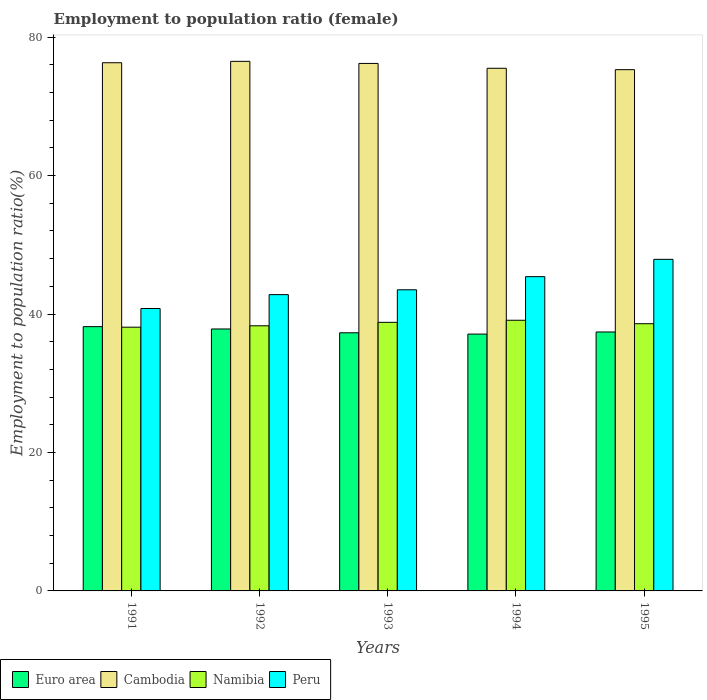Are the number of bars per tick equal to the number of legend labels?
Ensure brevity in your answer.  Yes. What is the label of the 3rd group of bars from the left?
Ensure brevity in your answer.  1993. What is the employment to population ratio in Euro area in 1995?
Keep it short and to the point. 37.41. Across all years, what is the maximum employment to population ratio in Namibia?
Your response must be concise. 39.1. Across all years, what is the minimum employment to population ratio in Cambodia?
Your response must be concise. 75.3. In which year was the employment to population ratio in Euro area maximum?
Your answer should be very brief. 1991. In which year was the employment to population ratio in Namibia minimum?
Ensure brevity in your answer.  1991. What is the total employment to population ratio in Euro area in the graph?
Provide a short and direct response. 187.81. What is the difference between the employment to population ratio in Namibia in 1991 and that in 1992?
Your response must be concise. -0.2. What is the difference between the employment to population ratio in Peru in 1993 and the employment to population ratio in Euro area in 1991?
Give a very brief answer. 5.32. What is the average employment to population ratio in Euro area per year?
Provide a succinct answer. 37.56. In the year 1994, what is the difference between the employment to population ratio in Cambodia and employment to population ratio in Namibia?
Keep it short and to the point. 36.4. What is the ratio of the employment to population ratio in Cambodia in 1992 to that in 1995?
Provide a short and direct response. 1.02. Is the employment to population ratio in Cambodia in 1993 less than that in 1995?
Make the answer very short. No. What is the difference between the highest and the second highest employment to population ratio in Peru?
Provide a short and direct response. 2.5. In how many years, is the employment to population ratio in Namibia greater than the average employment to population ratio in Namibia taken over all years?
Ensure brevity in your answer.  3. What does the 3rd bar from the left in 1994 represents?
Offer a very short reply. Namibia. How many bars are there?
Give a very brief answer. 20. How many years are there in the graph?
Offer a very short reply. 5. What is the difference between two consecutive major ticks on the Y-axis?
Give a very brief answer. 20. Does the graph contain any zero values?
Make the answer very short. No. Does the graph contain grids?
Provide a succinct answer. No. Where does the legend appear in the graph?
Ensure brevity in your answer.  Bottom left. How many legend labels are there?
Ensure brevity in your answer.  4. How are the legend labels stacked?
Ensure brevity in your answer.  Horizontal. What is the title of the graph?
Make the answer very short. Employment to population ratio (female). Does "Macao" appear as one of the legend labels in the graph?
Ensure brevity in your answer.  No. What is the label or title of the X-axis?
Your answer should be compact. Years. What is the Employment to population ratio(%) of Euro area in 1991?
Offer a terse response. 38.18. What is the Employment to population ratio(%) in Cambodia in 1991?
Make the answer very short. 76.3. What is the Employment to population ratio(%) in Namibia in 1991?
Give a very brief answer. 38.1. What is the Employment to population ratio(%) in Peru in 1991?
Your answer should be compact. 40.8. What is the Employment to population ratio(%) of Euro area in 1992?
Make the answer very short. 37.84. What is the Employment to population ratio(%) of Cambodia in 1992?
Keep it short and to the point. 76.5. What is the Employment to population ratio(%) of Namibia in 1992?
Your answer should be compact. 38.3. What is the Employment to population ratio(%) of Peru in 1992?
Offer a terse response. 42.8. What is the Employment to population ratio(%) of Euro area in 1993?
Ensure brevity in your answer.  37.29. What is the Employment to population ratio(%) in Cambodia in 1993?
Offer a very short reply. 76.2. What is the Employment to population ratio(%) in Namibia in 1993?
Offer a very short reply. 38.8. What is the Employment to population ratio(%) in Peru in 1993?
Make the answer very short. 43.5. What is the Employment to population ratio(%) of Euro area in 1994?
Provide a short and direct response. 37.1. What is the Employment to population ratio(%) in Cambodia in 1994?
Make the answer very short. 75.5. What is the Employment to population ratio(%) in Namibia in 1994?
Your answer should be very brief. 39.1. What is the Employment to population ratio(%) in Peru in 1994?
Your answer should be compact. 45.4. What is the Employment to population ratio(%) in Euro area in 1995?
Provide a succinct answer. 37.41. What is the Employment to population ratio(%) in Cambodia in 1995?
Provide a short and direct response. 75.3. What is the Employment to population ratio(%) of Namibia in 1995?
Offer a very short reply. 38.6. What is the Employment to population ratio(%) in Peru in 1995?
Offer a very short reply. 47.9. Across all years, what is the maximum Employment to population ratio(%) of Euro area?
Provide a succinct answer. 38.18. Across all years, what is the maximum Employment to population ratio(%) of Cambodia?
Your answer should be compact. 76.5. Across all years, what is the maximum Employment to population ratio(%) in Namibia?
Ensure brevity in your answer.  39.1. Across all years, what is the maximum Employment to population ratio(%) in Peru?
Offer a very short reply. 47.9. Across all years, what is the minimum Employment to population ratio(%) of Euro area?
Make the answer very short. 37.1. Across all years, what is the minimum Employment to population ratio(%) of Cambodia?
Offer a very short reply. 75.3. Across all years, what is the minimum Employment to population ratio(%) of Namibia?
Offer a very short reply. 38.1. Across all years, what is the minimum Employment to population ratio(%) of Peru?
Make the answer very short. 40.8. What is the total Employment to population ratio(%) in Euro area in the graph?
Your response must be concise. 187.81. What is the total Employment to population ratio(%) in Cambodia in the graph?
Offer a very short reply. 379.8. What is the total Employment to population ratio(%) of Namibia in the graph?
Keep it short and to the point. 192.9. What is the total Employment to population ratio(%) of Peru in the graph?
Make the answer very short. 220.4. What is the difference between the Employment to population ratio(%) of Euro area in 1991 and that in 1992?
Offer a very short reply. 0.34. What is the difference between the Employment to population ratio(%) of Cambodia in 1991 and that in 1992?
Provide a succinct answer. -0.2. What is the difference between the Employment to population ratio(%) of Euro area in 1991 and that in 1993?
Provide a succinct answer. 0.89. What is the difference between the Employment to population ratio(%) in Cambodia in 1991 and that in 1993?
Ensure brevity in your answer.  0.1. What is the difference between the Employment to population ratio(%) in Namibia in 1991 and that in 1993?
Give a very brief answer. -0.7. What is the difference between the Employment to population ratio(%) of Peru in 1991 and that in 1993?
Provide a short and direct response. -2.7. What is the difference between the Employment to population ratio(%) of Euro area in 1991 and that in 1994?
Offer a very short reply. 1.07. What is the difference between the Employment to population ratio(%) in Cambodia in 1991 and that in 1994?
Your answer should be very brief. 0.8. What is the difference between the Employment to population ratio(%) of Namibia in 1991 and that in 1994?
Give a very brief answer. -1. What is the difference between the Employment to population ratio(%) of Peru in 1991 and that in 1994?
Your answer should be very brief. -4.6. What is the difference between the Employment to population ratio(%) in Euro area in 1991 and that in 1995?
Provide a succinct answer. 0.77. What is the difference between the Employment to population ratio(%) of Euro area in 1992 and that in 1993?
Make the answer very short. 0.55. What is the difference between the Employment to population ratio(%) in Cambodia in 1992 and that in 1993?
Your answer should be compact. 0.3. What is the difference between the Employment to population ratio(%) in Euro area in 1992 and that in 1994?
Your answer should be compact. 0.74. What is the difference between the Employment to population ratio(%) in Cambodia in 1992 and that in 1994?
Offer a very short reply. 1. What is the difference between the Employment to population ratio(%) of Peru in 1992 and that in 1994?
Keep it short and to the point. -2.6. What is the difference between the Employment to population ratio(%) in Euro area in 1992 and that in 1995?
Your answer should be very brief. 0.43. What is the difference between the Employment to population ratio(%) in Namibia in 1992 and that in 1995?
Provide a succinct answer. -0.3. What is the difference between the Employment to population ratio(%) in Peru in 1992 and that in 1995?
Offer a terse response. -5.1. What is the difference between the Employment to population ratio(%) of Euro area in 1993 and that in 1994?
Give a very brief answer. 0.19. What is the difference between the Employment to population ratio(%) of Cambodia in 1993 and that in 1994?
Your response must be concise. 0.7. What is the difference between the Employment to population ratio(%) of Euro area in 1993 and that in 1995?
Provide a short and direct response. -0.12. What is the difference between the Employment to population ratio(%) in Peru in 1993 and that in 1995?
Offer a terse response. -4.4. What is the difference between the Employment to population ratio(%) in Euro area in 1994 and that in 1995?
Your answer should be very brief. -0.3. What is the difference between the Employment to population ratio(%) in Peru in 1994 and that in 1995?
Provide a succinct answer. -2.5. What is the difference between the Employment to population ratio(%) of Euro area in 1991 and the Employment to population ratio(%) of Cambodia in 1992?
Give a very brief answer. -38.32. What is the difference between the Employment to population ratio(%) in Euro area in 1991 and the Employment to population ratio(%) in Namibia in 1992?
Your answer should be very brief. -0.12. What is the difference between the Employment to population ratio(%) of Euro area in 1991 and the Employment to population ratio(%) of Peru in 1992?
Your response must be concise. -4.62. What is the difference between the Employment to population ratio(%) of Cambodia in 1991 and the Employment to population ratio(%) of Namibia in 1992?
Offer a terse response. 38. What is the difference between the Employment to population ratio(%) in Cambodia in 1991 and the Employment to population ratio(%) in Peru in 1992?
Ensure brevity in your answer.  33.5. What is the difference between the Employment to population ratio(%) of Namibia in 1991 and the Employment to population ratio(%) of Peru in 1992?
Give a very brief answer. -4.7. What is the difference between the Employment to population ratio(%) of Euro area in 1991 and the Employment to population ratio(%) of Cambodia in 1993?
Give a very brief answer. -38.02. What is the difference between the Employment to population ratio(%) of Euro area in 1991 and the Employment to population ratio(%) of Namibia in 1993?
Offer a terse response. -0.62. What is the difference between the Employment to population ratio(%) of Euro area in 1991 and the Employment to population ratio(%) of Peru in 1993?
Keep it short and to the point. -5.32. What is the difference between the Employment to population ratio(%) in Cambodia in 1991 and the Employment to population ratio(%) in Namibia in 1993?
Keep it short and to the point. 37.5. What is the difference between the Employment to population ratio(%) in Cambodia in 1991 and the Employment to population ratio(%) in Peru in 1993?
Offer a very short reply. 32.8. What is the difference between the Employment to population ratio(%) of Euro area in 1991 and the Employment to population ratio(%) of Cambodia in 1994?
Provide a short and direct response. -37.32. What is the difference between the Employment to population ratio(%) of Euro area in 1991 and the Employment to population ratio(%) of Namibia in 1994?
Ensure brevity in your answer.  -0.92. What is the difference between the Employment to population ratio(%) of Euro area in 1991 and the Employment to population ratio(%) of Peru in 1994?
Your answer should be very brief. -7.22. What is the difference between the Employment to population ratio(%) of Cambodia in 1991 and the Employment to population ratio(%) of Namibia in 1994?
Provide a succinct answer. 37.2. What is the difference between the Employment to population ratio(%) in Cambodia in 1991 and the Employment to population ratio(%) in Peru in 1994?
Offer a terse response. 30.9. What is the difference between the Employment to population ratio(%) in Namibia in 1991 and the Employment to population ratio(%) in Peru in 1994?
Ensure brevity in your answer.  -7.3. What is the difference between the Employment to population ratio(%) in Euro area in 1991 and the Employment to population ratio(%) in Cambodia in 1995?
Provide a short and direct response. -37.12. What is the difference between the Employment to population ratio(%) of Euro area in 1991 and the Employment to population ratio(%) of Namibia in 1995?
Your answer should be compact. -0.42. What is the difference between the Employment to population ratio(%) in Euro area in 1991 and the Employment to population ratio(%) in Peru in 1995?
Offer a very short reply. -9.72. What is the difference between the Employment to population ratio(%) of Cambodia in 1991 and the Employment to population ratio(%) of Namibia in 1995?
Ensure brevity in your answer.  37.7. What is the difference between the Employment to population ratio(%) in Cambodia in 1991 and the Employment to population ratio(%) in Peru in 1995?
Give a very brief answer. 28.4. What is the difference between the Employment to population ratio(%) of Namibia in 1991 and the Employment to population ratio(%) of Peru in 1995?
Your response must be concise. -9.8. What is the difference between the Employment to population ratio(%) of Euro area in 1992 and the Employment to population ratio(%) of Cambodia in 1993?
Provide a short and direct response. -38.36. What is the difference between the Employment to population ratio(%) in Euro area in 1992 and the Employment to population ratio(%) in Namibia in 1993?
Keep it short and to the point. -0.96. What is the difference between the Employment to population ratio(%) in Euro area in 1992 and the Employment to population ratio(%) in Peru in 1993?
Make the answer very short. -5.66. What is the difference between the Employment to population ratio(%) in Cambodia in 1992 and the Employment to population ratio(%) in Namibia in 1993?
Provide a short and direct response. 37.7. What is the difference between the Employment to population ratio(%) in Cambodia in 1992 and the Employment to population ratio(%) in Peru in 1993?
Your response must be concise. 33. What is the difference between the Employment to population ratio(%) in Euro area in 1992 and the Employment to population ratio(%) in Cambodia in 1994?
Make the answer very short. -37.66. What is the difference between the Employment to population ratio(%) of Euro area in 1992 and the Employment to population ratio(%) of Namibia in 1994?
Offer a terse response. -1.26. What is the difference between the Employment to population ratio(%) in Euro area in 1992 and the Employment to population ratio(%) in Peru in 1994?
Keep it short and to the point. -7.56. What is the difference between the Employment to population ratio(%) of Cambodia in 1992 and the Employment to population ratio(%) of Namibia in 1994?
Give a very brief answer. 37.4. What is the difference between the Employment to population ratio(%) in Cambodia in 1992 and the Employment to population ratio(%) in Peru in 1994?
Your answer should be very brief. 31.1. What is the difference between the Employment to population ratio(%) in Euro area in 1992 and the Employment to population ratio(%) in Cambodia in 1995?
Keep it short and to the point. -37.46. What is the difference between the Employment to population ratio(%) in Euro area in 1992 and the Employment to population ratio(%) in Namibia in 1995?
Your answer should be very brief. -0.76. What is the difference between the Employment to population ratio(%) of Euro area in 1992 and the Employment to population ratio(%) of Peru in 1995?
Offer a very short reply. -10.06. What is the difference between the Employment to population ratio(%) in Cambodia in 1992 and the Employment to population ratio(%) in Namibia in 1995?
Your answer should be very brief. 37.9. What is the difference between the Employment to population ratio(%) in Cambodia in 1992 and the Employment to population ratio(%) in Peru in 1995?
Give a very brief answer. 28.6. What is the difference between the Employment to population ratio(%) in Euro area in 1993 and the Employment to population ratio(%) in Cambodia in 1994?
Ensure brevity in your answer.  -38.21. What is the difference between the Employment to population ratio(%) of Euro area in 1993 and the Employment to population ratio(%) of Namibia in 1994?
Offer a terse response. -1.81. What is the difference between the Employment to population ratio(%) of Euro area in 1993 and the Employment to population ratio(%) of Peru in 1994?
Give a very brief answer. -8.11. What is the difference between the Employment to population ratio(%) in Cambodia in 1993 and the Employment to population ratio(%) in Namibia in 1994?
Your response must be concise. 37.1. What is the difference between the Employment to population ratio(%) of Cambodia in 1993 and the Employment to population ratio(%) of Peru in 1994?
Offer a very short reply. 30.8. What is the difference between the Employment to population ratio(%) in Euro area in 1993 and the Employment to population ratio(%) in Cambodia in 1995?
Offer a very short reply. -38.01. What is the difference between the Employment to population ratio(%) of Euro area in 1993 and the Employment to population ratio(%) of Namibia in 1995?
Ensure brevity in your answer.  -1.31. What is the difference between the Employment to population ratio(%) in Euro area in 1993 and the Employment to population ratio(%) in Peru in 1995?
Your answer should be compact. -10.61. What is the difference between the Employment to population ratio(%) in Cambodia in 1993 and the Employment to population ratio(%) in Namibia in 1995?
Your response must be concise. 37.6. What is the difference between the Employment to population ratio(%) in Cambodia in 1993 and the Employment to population ratio(%) in Peru in 1995?
Make the answer very short. 28.3. What is the difference between the Employment to population ratio(%) of Euro area in 1994 and the Employment to population ratio(%) of Cambodia in 1995?
Offer a terse response. -38.2. What is the difference between the Employment to population ratio(%) in Euro area in 1994 and the Employment to population ratio(%) in Namibia in 1995?
Make the answer very short. -1.5. What is the difference between the Employment to population ratio(%) in Euro area in 1994 and the Employment to population ratio(%) in Peru in 1995?
Ensure brevity in your answer.  -10.8. What is the difference between the Employment to population ratio(%) of Cambodia in 1994 and the Employment to population ratio(%) of Namibia in 1995?
Give a very brief answer. 36.9. What is the difference between the Employment to population ratio(%) in Cambodia in 1994 and the Employment to population ratio(%) in Peru in 1995?
Your answer should be compact. 27.6. What is the average Employment to population ratio(%) of Euro area per year?
Give a very brief answer. 37.56. What is the average Employment to population ratio(%) of Cambodia per year?
Offer a very short reply. 75.96. What is the average Employment to population ratio(%) in Namibia per year?
Your answer should be very brief. 38.58. What is the average Employment to population ratio(%) in Peru per year?
Give a very brief answer. 44.08. In the year 1991, what is the difference between the Employment to population ratio(%) in Euro area and Employment to population ratio(%) in Cambodia?
Your response must be concise. -38.12. In the year 1991, what is the difference between the Employment to population ratio(%) in Euro area and Employment to population ratio(%) in Namibia?
Your answer should be compact. 0.08. In the year 1991, what is the difference between the Employment to population ratio(%) in Euro area and Employment to population ratio(%) in Peru?
Your answer should be very brief. -2.62. In the year 1991, what is the difference between the Employment to population ratio(%) of Cambodia and Employment to population ratio(%) of Namibia?
Provide a short and direct response. 38.2. In the year 1991, what is the difference between the Employment to population ratio(%) in Cambodia and Employment to population ratio(%) in Peru?
Ensure brevity in your answer.  35.5. In the year 1992, what is the difference between the Employment to population ratio(%) of Euro area and Employment to population ratio(%) of Cambodia?
Provide a succinct answer. -38.66. In the year 1992, what is the difference between the Employment to population ratio(%) in Euro area and Employment to population ratio(%) in Namibia?
Provide a succinct answer. -0.46. In the year 1992, what is the difference between the Employment to population ratio(%) of Euro area and Employment to population ratio(%) of Peru?
Your response must be concise. -4.96. In the year 1992, what is the difference between the Employment to population ratio(%) of Cambodia and Employment to population ratio(%) of Namibia?
Your answer should be very brief. 38.2. In the year 1992, what is the difference between the Employment to population ratio(%) of Cambodia and Employment to population ratio(%) of Peru?
Provide a short and direct response. 33.7. In the year 1992, what is the difference between the Employment to population ratio(%) of Namibia and Employment to population ratio(%) of Peru?
Offer a terse response. -4.5. In the year 1993, what is the difference between the Employment to population ratio(%) in Euro area and Employment to population ratio(%) in Cambodia?
Offer a terse response. -38.91. In the year 1993, what is the difference between the Employment to population ratio(%) in Euro area and Employment to population ratio(%) in Namibia?
Offer a terse response. -1.51. In the year 1993, what is the difference between the Employment to population ratio(%) of Euro area and Employment to population ratio(%) of Peru?
Give a very brief answer. -6.21. In the year 1993, what is the difference between the Employment to population ratio(%) in Cambodia and Employment to population ratio(%) in Namibia?
Your answer should be very brief. 37.4. In the year 1993, what is the difference between the Employment to population ratio(%) of Cambodia and Employment to population ratio(%) of Peru?
Offer a very short reply. 32.7. In the year 1994, what is the difference between the Employment to population ratio(%) in Euro area and Employment to population ratio(%) in Cambodia?
Provide a short and direct response. -38.4. In the year 1994, what is the difference between the Employment to population ratio(%) of Euro area and Employment to population ratio(%) of Namibia?
Offer a very short reply. -2. In the year 1994, what is the difference between the Employment to population ratio(%) of Euro area and Employment to population ratio(%) of Peru?
Offer a very short reply. -8.3. In the year 1994, what is the difference between the Employment to population ratio(%) of Cambodia and Employment to population ratio(%) of Namibia?
Give a very brief answer. 36.4. In the year 1994, what is the difference between the Employment to population ratio(%) in Cambodia and Employment to population ratio(%) in Peru?
Offer a terse response. 30.1. In the year 1995, what is the difference between the Employment to population ratio(%) in Euro area and Employment to population ratio(%) in Cambodia?
Your answer should be compact. -37.89. In the year 1995, what is the difference between the Employment to population ratio(%) of Euro area and Employment to population ratio(%) of Namibia?
Offer a terse response. -1.19. In the year 1995, what is the difference between the Employment to population ratio(%) in Euro area and Employment to population ratio(%) in Peru?
Ensure brevity in your answer.  -10.49. In the year 1995, what is the difference between the Employment to population ratio(%) in Cambodia and Employment to population ratio(%) in Namibia?
Ensure brevity in your answer.  36.7. In the year 1995, what is the difference between the Employment to population ratio(%) of Cambodia and Employment to population ratio(%) of Peru?
Your answer should be very brief. 27.4. What is the ratio of the Employment to population ratio(%) of Euro area in 1991 to that in 1992?
Your response must be concise. 1.01. What is the ratio of the Employment to population ratio(%) in Namibia in 1991 to that in 1992?
Make the answer very short. 0.99. What is the ratio of the Employment to population ratio(%) in Peru in 1991 to that in 1992?
Ensure brevity in your answer.  0.95. What is the ratio of the Employment to population ratio(%) in Euro area in 1991 to that in 1993?
Your answer should be compact. 1.02. What is the ratio of the Employment to population ratio(%) of Peru in 1991 to that in 1993?
Keep it short and to the point. 0.94. What is the ratio of the Employment to population ratio(%) in Euro area in 1991 to that in 1994?
Your response must be concise. 1.03. What is the ratio of the Employment to population ratio(%) of Cambodia in 1991 to that in 1994?
Offer a terse response. 1.01. What is the ratio of the Employment to population ratio(%) of Namibia in 1991 to that in 1994?
Keep it short and to the point. 0.97. What is the ratio of the Employment to population ratio(%) in Peru in 1991 to that in 1994?
Your answer should be very brief. 0.9. What is the ratio of the Employment to population ratio(%) of Euro area in 1991 to that in 1995?
Your answer should be compact. 1.02. What is the ratio of the Employment to population ratio(%) of Cambodia in 1991 to that in 1995?
Offer a very short reply. 1.01. What is the ratio of the Employment to population ratio(%) of Namibia in 1991 to that in 1995?
Give a very brief answer. 0.99. What is the ratio of the Employment to population ratio(%) in Peru in 1991 to that in 1995?
Give a very brief answer. 0.85. What is the ratio of the Employment to population ratio(%) in Euro area in 1992 to that in 1993?
Ensure brevity in your answer.  1.01. What is the ratio of the Employment to population ratio(%) of Namibia in 1992 to that in 1993?
Provide a short and direct response. 0.99. What is the ratio of the Employment to population ratio(%) of Peru in 1992 to that in 1993?
Ensure brevity in your answer.  0.98. What is the ratio of the Employment to population ratio(%) in Euro area in 1992 to that in 1994?
Ensure brevity in your answer.  1.02. What is the ratio of the Employment to population ratio(%) in Cambodia in 1992 to that in 1994?
Your response must be concise. 1.01. What is the ratio of the Employment to population ratio(%) of Namibia in 1992 to that in 1994?
Offer a very short reply. 0.98. What is the ratio of the Employment to population ratio(%) in Peru in 1992 to that in 1994?
Offer a terse response. 0.94. What is the ratio of the Employment to population ratio(%) in Euro area in 1992 to that in 1995?
Keep it short and to the point. 1.01. What is the ratio of the Employment to population ratio(%) of Cambodia in 1992 to that in 1995?
Keep it short and to the point. 1.02. What is the ratio of the Employment to population ratio(%) in Peru in 1992 to that in 1995?
Give a very brief answer. 0.89. What is the ratio of the Employment to population ratio(%) of Euro area in 1993 to that in 1994?
Keep it short and to the point. 1.01. What is the ratio of the Employment to population ratio(%) in Cambodia in 1993 to that in 1994?
Ensure brevity in your answer.  1.01. What is the ratio of the Employment to population ratio(%) of Peru in 1993 to that in 1994?
Ensure brevity in your answer.  0.96. What is the ratio of the Employment to population ratio(%) in Peru in 1993 to that in 1995?
Your response must be concise. 0.91. What is the ratio of the Employment to population ratio(%) in Cambodia in 1994 to that in 1995?
Your answer should be very brief. 1. What is the ratio of the Employment to population ratio(%) in Namibia in 1994 to that in 1995?
Keep it short and to the point. 1.01. What is the ratio of the Employment to population ratio(%) of Peru in 1994 to that in 1995?
Keep it short and to the point. 0.95. What is the difference between the highest and the second highest Employment to population ratio(%) of Euro area?
Provide a short and direct response. 0.34. What is the difference between the highest and the second highest Employment to population ratio(%) of Namibia?
Offer a terse response. 0.3. What is the difference between the highest and the lowest Employment to population ratio(%) in Euro area?
Your response must be concise. 1.07. What is the difference between the highest and the lowest Employment to population ratio(%) of Namibia?
Give a very brief answer. 1. 